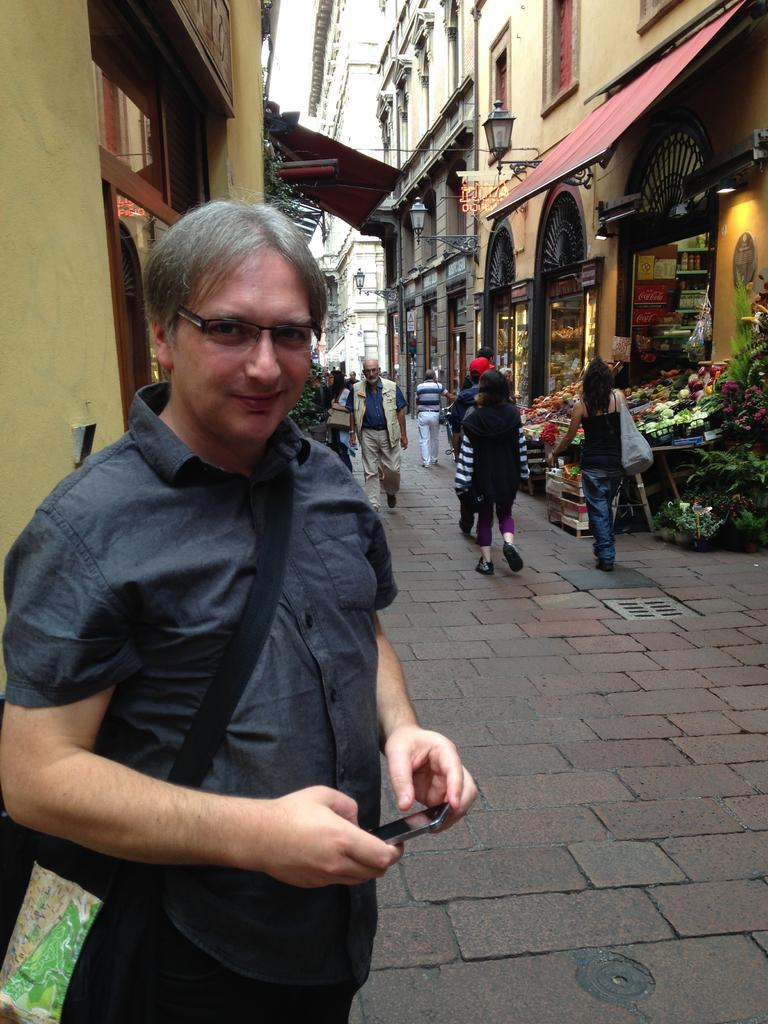What type of structures can be seen in the image? There are buildings in the image. What are the people near the buildings doing? There are persons standing on the roadside. What type of business or activity is depicted in the image? There is a vegetable stall in the image. What is the source of illumination at night in the image? There is a street light in the image. What type of cooking or grilling equipment is visible in the image? There are grills in the image. What type of jewel is being sold at the vegetable stall in the image? There is no mention of a jewel or any jewelry-related items being sold at the vegetable stall in the image. What type of hat is being worn by the person standing on the roadside in the image? There is no mention of a hat or any headwear being worn by the persons standing on the roadside in the image. 